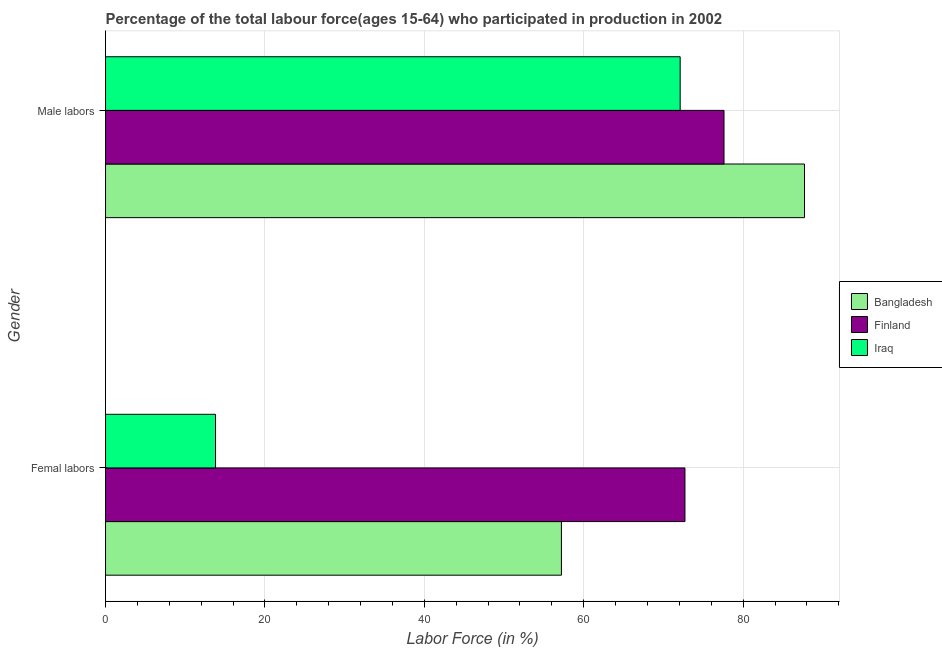How many different coloured bars are there?
Your response must be concise. 3. How many groups of bars are there?
Keep it short and to the point. 2. How many bars are there on the 2nd tick from the top?
Give a very brief answer. 3. What is the label of the 1st group of bars from the top?
Provide a short and direct response. Male labors. What is the percentage of male labour force in Finland?
Offer a terse response. 77.6. Across all countries, what is the maximum percentage of male labour force?
Your response must be concise. 87.7. Across all countries, what is the minimum percentage of male labour force?
Your response must be concise. 72.1. In which country was the percentage of male labour force maximum?
Your answer should be very brief. Bangladesh. In which country was the percentage of female labor force minimum?
Your response must be concise. Iraq. What is the total percentage of male labour force in the graph?
Give a very brief answer. 237.4. What is the difference between the percentage of female labor force in Finland and that in Bangladesh?
Ensure brevity in your answer.  15.5. What is the difference between the percentage of female labor force in Bangladesh and the percentage of male labour force in Finland?
Your answer should be compact. -20.4. What is the average percentage of female labor force per country?
Your answer should be compact. 47.9. What is the difference between the percentage of male labour force and percentage of female labor force in Iraq?
Make the answer very short. 58.3. What is the ratio of the percentage of female labor force in Finland to that in Iraq?
Ensure brevity in your answer.  5.27. Is the percentage of female labor force in Finland less than that in Bangladesh?
Your answer should be compact. No. In how many countries, is the percentage of female labor force greater than the average percentage of female labor force taken over all countries?
Provide a short and direct response. 2. What does the 2nd bar from the top in Femal labors represents?
Offer a terse response. Finland. What does the 3rd bar from the bottom in Male labors represents?
Provide a succinct answer. Iraq. How many bars are there?
Offer a very short reply. 6. How many countries are there in the graph?
Keep it short and to the point. 3. What is the difference between two consecutive major ticks on the X-axis?
Ensure brevity in your answer.  20. Are the values on the major ticks of X-axis written in scientific E-notation?
Provide a short and direct response. No. Does the graph contain any zero values?
Your response must be concise. No. Does the graph contain grids?
Provide a succinct answer. Yes. How are the legend labels stacked?
Your answer should be very brief. Vertical. What is the title of the graph?
Keep it short and to the point. Percentage of the total labour force(ages 15-64) who participated in production in 2002. Does "Low & middle income" appear as one of the legend labels in the graph?
Your response must be concise. No. What is the label or title of the X-axis?
Your answer should be compact. Labor Force (in %). What is the label or title of the Y-axis?
Keep it short and to the point. Gender. What is the Labor Force (in %) in Bangladesh in Femal labors?
Offer a very short reply. 57.2. What is the Labor Force (in %) in Finland in Femal labors?
Make the answer very short. 72.7. What is the Labor Force (in %) in Iraq in Femal labors?
Provide a short and direct response. 13.8. What is the Labor Force (in %) in Bangladesh in Male labors?
Make the answer very short. 87.7. What is the Labor Force (in %) in Finland in Male labors?
Give a very brief answer. 77.6. What is the Labor Force (in %) in Iraq in Male labors?
Your response must be concise. 72.1. Across all Gender, what is the maximum Labor Force (in %) of Bangladesh?
Keep it short and to the point. 87.7. Across all Gender, what is the maximum Labor Force (in %) of Finland?
Provide a succinct answer. 77.6. Across all Gender, what is the maximum Labor Force (in %) in Iraq?
Ensure brevity in your answer.  72.1. Across all Gender, what is the minimum Labor Force (in %) in Bangladesh?
Provide a short and direct response. 57.2. Across all Gender, what is the minimum Labor Force (in %) in Finland?
Provide a succinct answer. 72.7. Across all Gender, what is the minimum Labor Force (in %) in Iraq?
Provide a short and direct response. 13.8. What is the total Labor Force (in %) of Bangladesh in the graph?
Give a very brief answer. 144.9. What is the total Labor Force (in %) of Finland in the graph?
Provide a succinct answer. 150.3. What is the total Labor Force (in %) of Iraq in the graph?
Provide a succinct answer. 85.9. What is the difference between the Labor Force (in %) in Bangladesh in Femal labors and that in Male labors?
Offer a very short reply. -30.5. What is the difference between the Labor Force (in %) of Finland in Femal labors and that in Male labors?
Ensure brevity in your answer.  -4.9. What is the difference between the Labor Force (in %) in Iraq in Femal labors and that in Male labors?
Offer a terse response. -58.3. What is the difference between the Labor Force (in %) of Bangladesh in Femal labors and the Labor Force (in %) of Finland in Male labors?
Offer a terse response. -20.4. What is the difference between the Labor Force (in %) of Bangladesh in Femal labors and the Labor Force (in %) of Iraq in Male labors?
Keep it short and to the point. -14.9. What is the average Labor Force (in %) in Bangladesh per Gender?
Offer a terse response. 72.45. What is the average Labor Force (in %) in Finland per Gender?
Your response must be concise. 75.15. What is the average Labor Force (in %) of Iraq per Gender?
Ensure brevity in your answer.  42.95. What is the difference between the Labor Force (in %) of Bangladesh and Labor Force (in %) of Finland in Femal labors?
Your answer should be very brief. -15.5. What is the difference between the Labor Force (in %) of Bangladesh and Labor Force (in %) of Iraq in Femal labors?
Offer a terse response. 43.4. What is the difference between the Labor Force (in %) of Finland and Labor Force (in %) of Iraq in Femal labors?
Offer a very short reply. 58.9. What is the difference between the Labor Force (in %) of Bangladesh and Labor Force (in %) of Finland in Male labors?
Your answer should be very brief. 10.1. What is the ratio of the Labor Force (in %) in Bangladesh in Femal labors to that in Male labors?
Offer a very short reply. 0.65. What is the ratio of the Labor Force (in %) of Finland in Femal labors to that in Male labors?
Your response must be concise. 0.94. What is the ratio of the Labor Force (in %) in Iraq in Femal labors to that in Male labors?
Your answer should be very brief. 0.19. What is the difference between the highest and the second highest Labor Force (in %) in Bangladesh?
Your answer should be compact. 30.5. What is the difference between the highest and the second highest Labor Force (in %) in Finland?
Provide a short and direct response. 4.9. What is the difference between the highest and the second highest Labor Force (in %) in Iraq?
Your answer should be compact. 58.3. What is the difference between the highest and the lowest Labor Force (in %) of Bangladesh?
Provide a short and direct response. 30.5. What is the difference between the highest and the lowest Labor Force (in %) in Iraq?
Your answer should be compact. 58.3. 